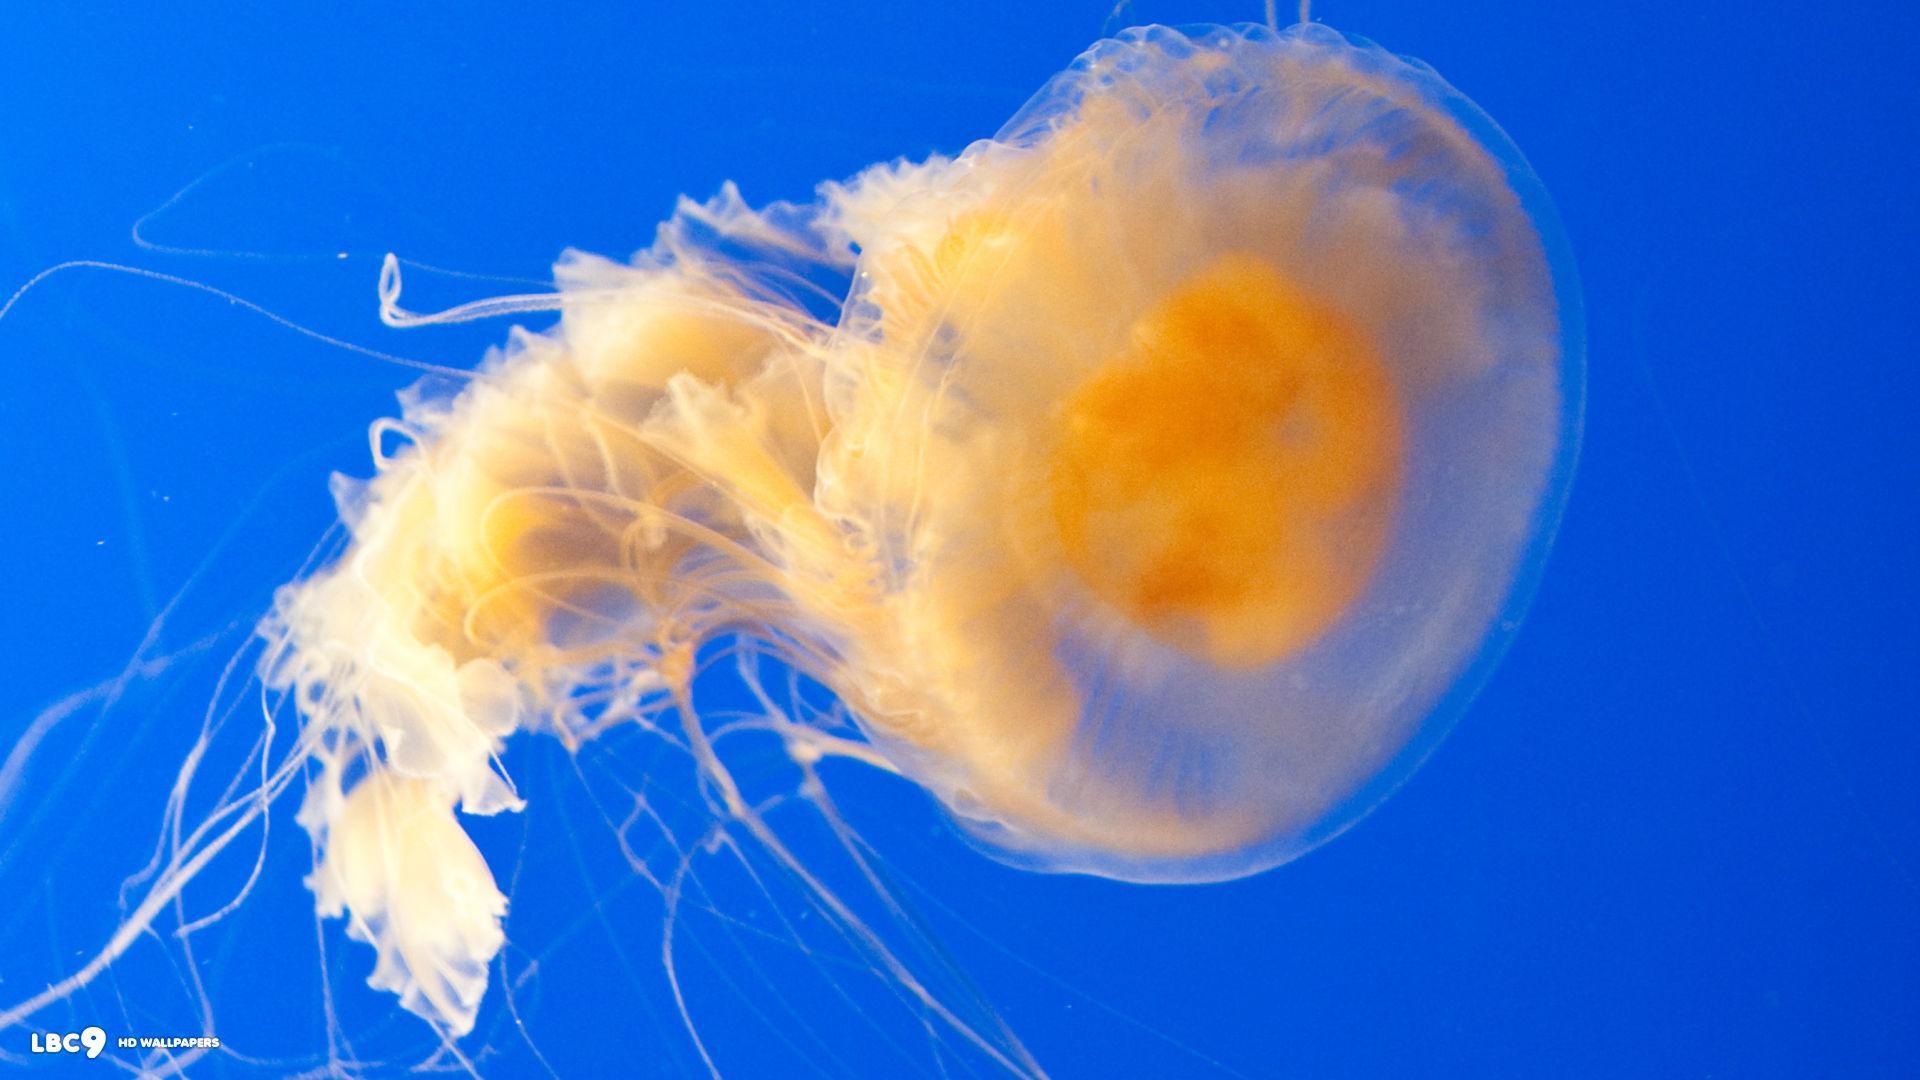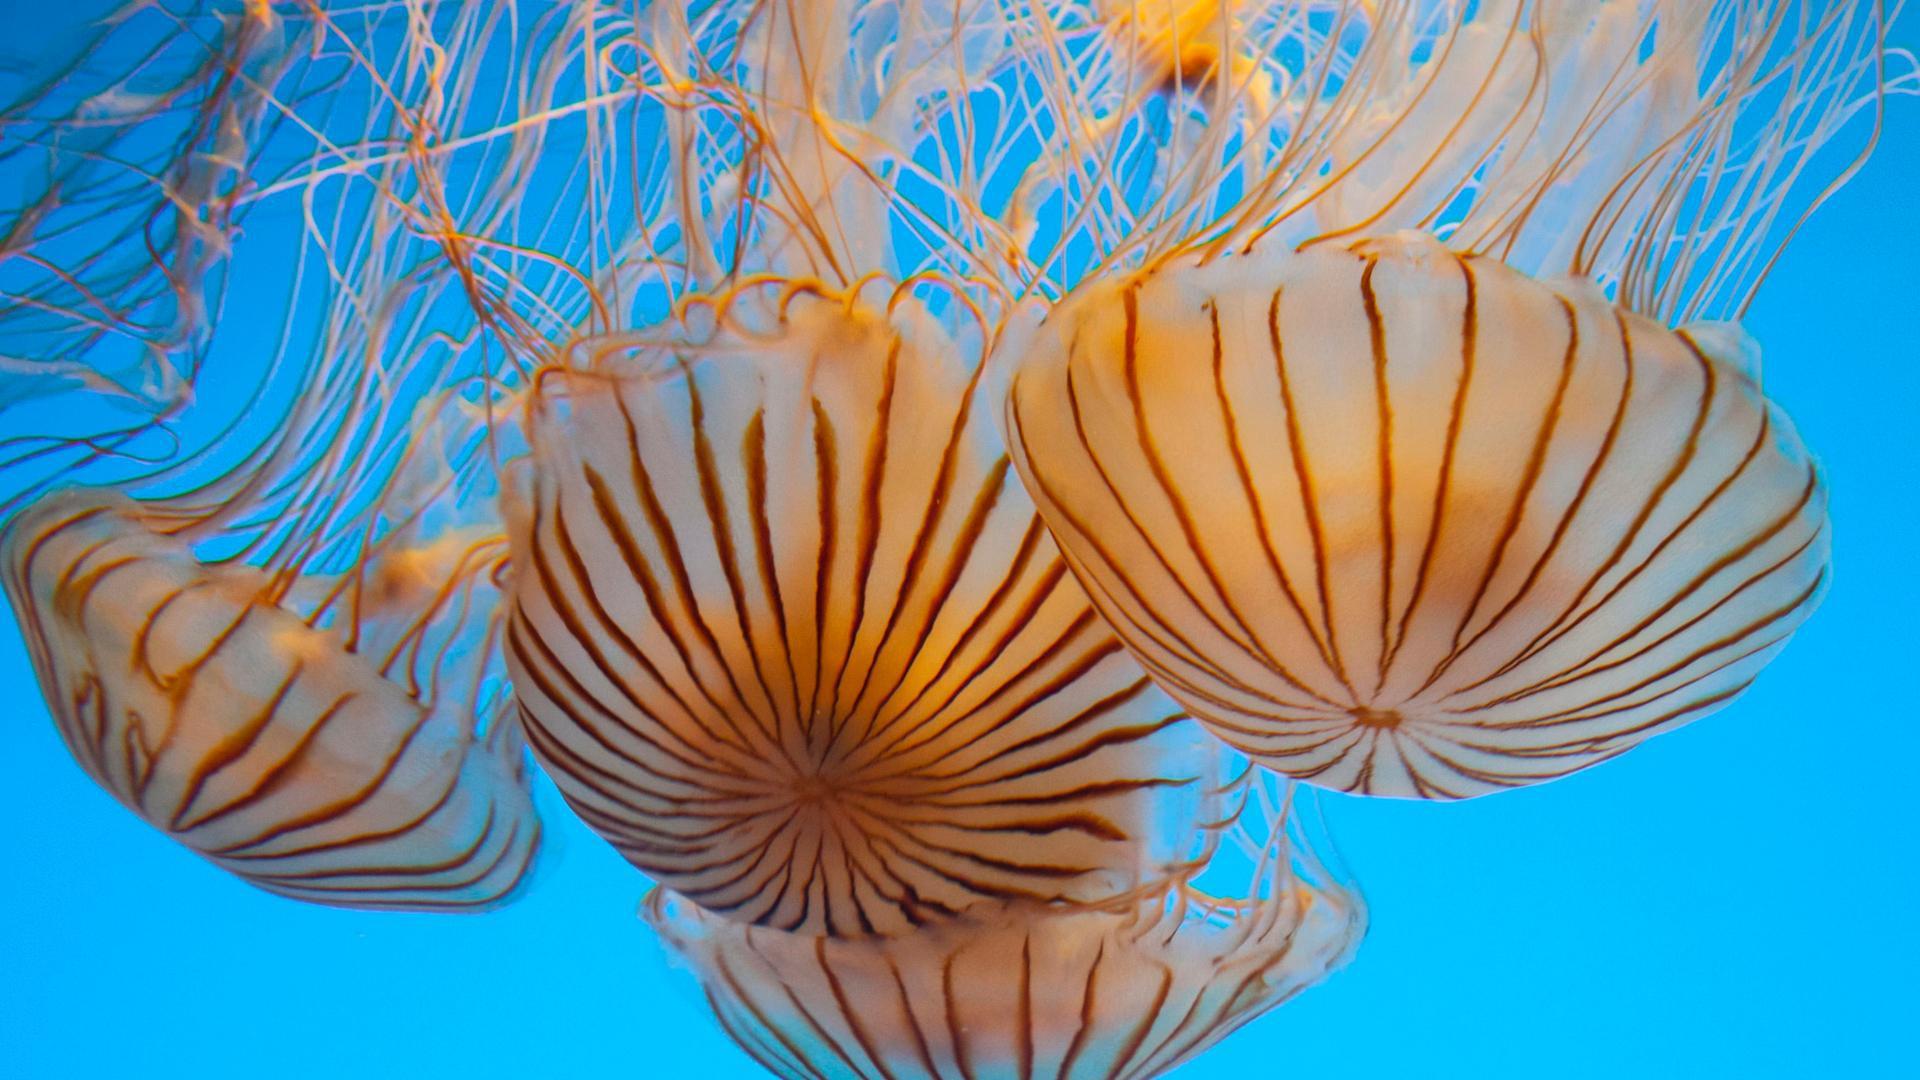The first image is the image on the left, the second image is the image on the right. Analyze the images presented: Is the assertion "the body of the jellyfish has dark stripes" valid? Answer yes or no. Yes. The first image is the image on the left, the second image is the image on the right. Examine the images to the left and right. Is the description "At least one jellyfish has a striped top." accurate? Answer yes or no. Yes. 